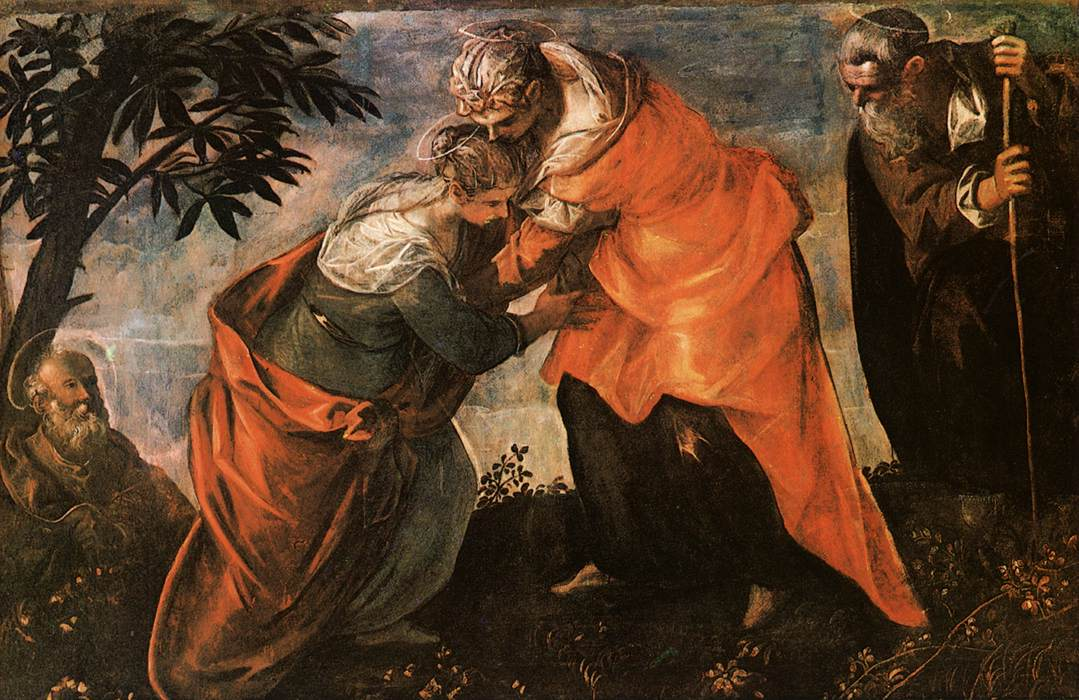Now, narrate an extended realistic scenario drawn from this image, highlighting the emotions and environment. In the lush, secluded garden, dappled sunlight filters through the broad canopy of ancient trees, casting gentle, shifting patterns of light and shadow upon the ground. The air is thick with the scents of blooming flowers and earthy foliage. Birds chirp softly, and a gentle breeze stirs the leaves, creating a serene environment for this momentous occasion.

Mary, with an expression of earnest humility and radiant joy, approaches her cousin Elizabeth. Elizabeth, whose face glows with an inner light, greets Mary with a profound sense of wonder and reverence, feeling her unborn child leap within her at the sound of Mary’s greeting. This moment is filled with a layered mix of emotions – joy, awe, and a deep spiritual connection.

Elizabeth exclaims, 'Blessed are you among women, and blessed is the fruit of your womb! But why am I so favored, that the mother of my Lord should come to me?' Her words resonate with both gratitude and a heartfelt acknowledgment of the divine significance of Mary’s child.

Meanwhile, Joseph stands a short distance away, leaning on a staff, his face a mix of contemplation and serene acceptance. His presence adds a sense of grounded support, embodying strength and silent understanding.

As the women speak, the garden seems to come alive with the energy of their sacred encounter. The trees, as if bearing silent witness, sway gently, their leaves rustling like soft applause. Flowers bloom more vividly, their colors becoming more pronounced in the soft sunlight.

The entire setting exudes a palpable sense of peace and divine purpose. It is as if time itself pauses, allowing the sacredness of this reunion to permeate the very air, embedding this moment into the timeless tapestry of faith and prophecy. 